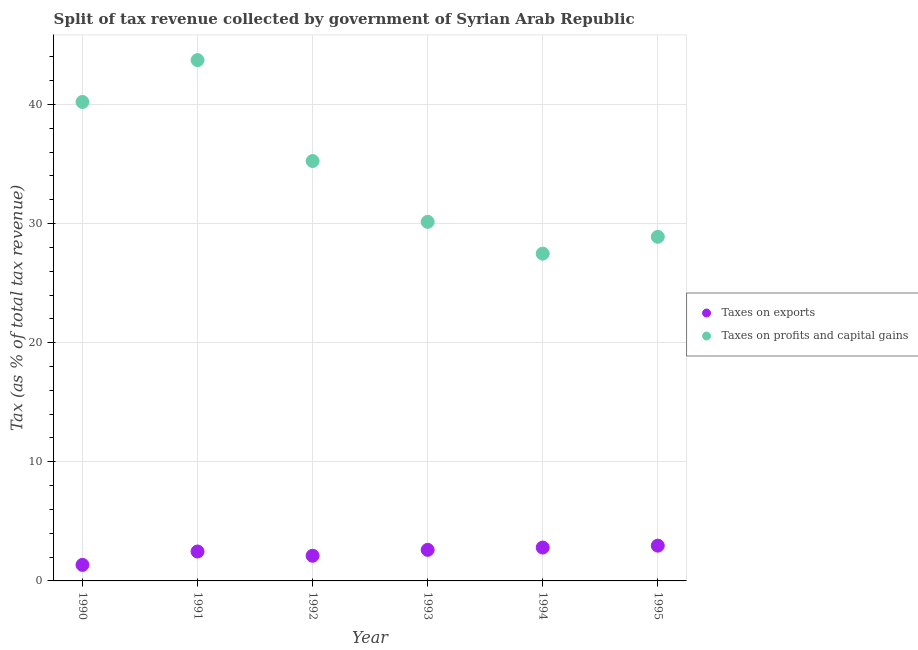How many different coloured dotlines are there?
Offer a very short reply. 2. Is the number of dotlines equal to the number of legend labels?
Offer a very short reply. Yes. What is the percentage of revenue obtained from taxes on profits and capital gains in 1995?
Offer a very short reply. 28.89. Across all years, what is the maximum percentage of revenue obtained from taxes on exports?
Ensure brevity in your answer.  2.96. Across all years, what is the minimum percentage of revenue obtained from taxes on exports?
Offer a terse response. 1.35. In which year was the percentage of revenue obtained from taxes on exports minimum?
Ensure brevity in your answer.  1990. What is the total percentage of revenue obtained from taxes on profits and capital gains in the graph?
Offer a very short reply. 205.68. What is the difference between the percentage of revenue obtained from taxes on exports in 1990 and that in 1991?
Your answer should be compact. -1.12. What is the difference between the percentage of revenue obtained from taxes on profits and capital gains in 1990 and the percentage of revenue obtained from taxes on exports in 1995?
Provide a succinct answer. 37.24. What is the average percentage of revenue obtained from taxes on profits and capital gains per year?
Provide a short and direct response. 34.28. In the year 1991, what is the difference between the percentage of revenue obtained from taxes on profits and capital gains and percentage of revenue obtained from taxes on exports?
Keep it short and to the point. 41.25. What is the ratio of the percentage of revenue obtained from taxes on exports in 1991 to that in 1993?
Keep it short and to the point. 0.95. Is the percentage of revenue obtained from taxes on profits and capital gains in 1990 less than that in 1995?
Provide a short and direct response. No. What is the difference between the highest and the second highest percentage of revenue obtained from taxes on profits and capital gains?
Your answer should be compact. 3.52. What is the difference between the highest and the lowest percentage of revenue obtained from taxes on exports?
Keep it short and to the point. 1.61. In how many years, is the percentage of revenue obtained from taxes on profits and capital gains greater than the average percentage of revenue obtained from taxes on profits and capital gains taken over all years?
Provide a succinct answer. 3. Is the percentage of revenue obtained from taxes on profits and capital gains strictly less than the percentage of revenue obtained from taxes on exports over the years?
Offer a very short reply. No. How many dotlines are there?
Offer a very short reply. 2. How many years are there in the graph?
Keep it short and to the point. 6. Does the graph contain grids?
Your answer should be very brief. Yes. Where does the legend appear in the graph?
Provide a short and direct response. Center right. How many legend labels are there?
Offer a very short reply. 2. What is the title of the graph?
Keep it short and to the point. Split of tax revenue collected by government of Syrian Arab Republic. Does "US$" appear as one of the legend labels in the graph?
Provide a succinct answer. No. What is the label or title of the X-axis?
Give a very brief answer. Year. What is the label or title of the Y-axis?
Your response must be concise. Tax (as % of total tax revenue). What is the Tax (as % of total tax revenue) in Taxes on exports in 1990?
Provide a succinct answer. 1.35. What is the Tax (as % of total tax revenue) in Taxes on profits and capital gains in 1990?
Give a very brief answer. 40.2. What is the Tax (as % of total tax revenue) of Taxes on exports in 1991?
Your answer should be compact. 2.47. What is the Tax (as % of total tax revenue) in Taxes on profits and capital gains in 1991?
Provide a short and direct response. 43.72. What is the Tax (as % of total tax revenue) in Taxes on exports in 1992?
Provide a succinct answer. 2.11. What is the Tax (as % of total tax revenue) in Taxes on profits and capital gains in 1992?
Your answer should be very brief. 35.25. What is the Tax (as % of total tax revenue) in Taxes on exports in 1993?
Provide a short and direct response. 2.61. What is the Tax (as % of total tax revenue) in Taxes on profits and capital gains in 1993?
Offer a very short reply. 30.14. What is the Tax (as % of total tax revenue) of Taxes on exports in 1994?
Offer a very short reply. 2.8. What is the Tax (as % of total tax revenue) of Taxes on profits and capital gains in 1994?
Your response must be concise. 27.47. What is the Tax (as % of total tax revenue) in Taxes on exports in 1995?
Keep it short and to the point. 2.96. What is the Tax (as % of total tax revenue) in Taxes on profits and capital gains in 1995?
Offer a terse response. 28.89. Across all years, what is the maximum Tax (as % of total tax revenue) in Taxes on exports?
Provide a succinct answer. 2.96. Across all years, what is the maximum Tax (as % of total tax revenue) in Taxes on profits and capital gains?
Provide a short and direct response. 43.72. Across all years, what is the minimum Tax (as % of total tax revenue) of Taxes on exports?
Offer a very short reply. 1.35. Across all years, what is the minimum Tax (as % of total tax revenue) in Taxes on profits and capital gains?
Provide a succinct answer. 27.47. What is the total Tax (as % of total tax revenue) of Taxes on exports in the graph?
Provide a short and direct response. 14.3. What is the total Tax (as % of total tax revenue) of Taxes on profits and capital gains in the graph?
Give a very brief answer. 205.68. What is the difference between the Tax (as % of total tax revenue) in Taxes on exports in 1990 and that in 1991?
Give a very brief answer. -1.12. What is the difference between the Tax (as % of total tax revenue) in Taxes on profits and capital gains in 1990 and that in 1991?
Your answer should be compact. -3.52. What is the difference between the Tax (as % of total tax revenue) of Taxes on exports in 1990 and that in 1992?
Offer a very short reply. -0.77. What is the difference between the Tax (as % of total tax revenue) of Taxes on profits and capital gains in 1990 and that in 1992?
Your response must be concise. 4.96. What is the difference between the Tax (as % of total tax revenue) in Taxes on exports in 1990 and that in 1993?
Your answer should be compact. -1.26. What is the difference between the Tax (as % of total tax revenue) of Taxes on profits and capital gains in 1990 and that in 1993?
Offer a terse response. 10.06. What is the difference between the Tax (as % of total tax revenue) in Taxes on exports in 1990 and that in 1994?
Offer a very short reply. -1.45. What is the difference between the Tax (as % of total tax revenue) in Taxes on profits and capital gains in 1990 and that in 1994?
Offer a terse response. 12.73. What is the difference between the Tax (as % of total tax revenue) of Taxes on exports in 1990 and that in 1995?
Make the answer very short. -1.61. What is the difference between the Tax (as % of total tax revenue) of Taxes on profits and capital gains in 1990 and that in 1995?
Your answer should be very brief. 11.32. What is the difference between the Tax (as % of total tax revenue) in Taxes on exports in 1991 and that in 1992?
Give a very brief answer. 0.36. What is the difference between the Tax (as % of total tax revenue) of Taxes on profits and capital gains in 1991 and that in 1992?
Ensure brevity in your answer.  8.47. What is the difference between the Tax (as % of total tax revenue) of Taxes on exports in 1991 and that in 1993?
Provide a short and direct response. -0.14. What is the difference between the Tax (as % of total tax revenue) of Taxes on profits and capital gains in 1991 and that in 1993?
Your answer should be compact. 13.58. What is the difference between the Tax (as % of total tax revenue) in Taxes on exports in 1991 and that in 1994?
Give a very brief answer. -0.33. What is the difference between the Tax (as % of total tax revenue) of Taxes on profits and capital gains in 1991 and that in 1994?
Your answer should be compact. 16.25. What is the difference between the Tax (as % of total tax revenue) of Taxes on exports in 1991 and that in 1995?
Your answer should be very brief. -0.49. What is the difference between the Tax (as % of total tax revenue) in Taxes on profits and capital gains in 1991 and that in 1995?
Your response must be concise. 14.83. What is the difference between the Tax (as % of total tax revenue) in Taxes on exports in 1992 and that in 1993?
Your answer should be very brief. -0.49. What is the difference between the Tax (as % of total tax revenue) of Taxes on profits and capital gains in 1992 and that in 1993?
Provide a short and direct response. 5.11. What is the difference between the Tax (as % of total tax revenue) of Taxes on exports in 1992 and that in 1994?
Give a very brief answer. -0.69. What is the difference between the Tax (as % of total tax revenue) of Taxes on profits and capital gains in 1992 and that in 1994?
Offer a terse response. 7.77. What is the difference between the Tax (as % of total tax revenue) of Taxes on exports in 1992 and that in 1995?
Offer a very short reply. -0.85. What is the difference between the Tax (as % of total tax revenue) of Taxes on profits and capital gains in 1992 and that in 1995?
Give a very brief answer. 6.36. What is the difference between the Tax (as % of total tax revenue) in Taxes on exports in 1993 and that in 1994?
Offer a terse response. -0.19. What is the difference between the Tax (as % of total tax revenue) in Taxes on profits and capital gains in 1993 and that in 1994?
Your answer should be very brief. 2.67. What is the difference between the Tax (as % of total tax revenue) in Taxes on exports in 1993 and that in 1995?
Offer a very short reply. -0.35. What is the difference between the Tax (as % of total tax revenue) of Taxes on profits and capital gains in 1993 and that in 1995?
Your response must be concise. 1.26. What is the difference between the Tax (as % of total tax revenue) of Taxes on exports in 1994 and that in 1995?
Keep it short and to the point. -0.16. What is the difference between the Tax (as % of total tax revenue) in Taxes on profits and capital gains in 1994 and that in 1995?
Your response must be concise. -1.41. What is the difference between the Tax (as % of total tax revenue) in Taxes on exports in 1990 and the Tax (as % of total tax revenue) in Taxes on profits and capital gains in 1991?
Ensure brevity in your answer.  -42.37. What is the difference between the Tax (as % of total tax revenue) of Taxes on exports in 1990 and the Tax (as % of total tax revenue) of Taxes on profits and capital gains in 1992?
Your answer should be compact. -33.9. What is the difference between the Tax (as % of total tax revenue) of Taxes on exports in 1990 and the Tax (as % of total tax revenue) of Taxes on profits and capital gains in 1993?
Make the answer very short. -28.8. What is the difference between the Tax (as % of total tax revenue) of Taxes on exports in 1990 and the Tax (as % of total tax revenue) of Taxes on profits and capital gains in 1994?
Give a very brief answer. -26.13. What is the difference between the Tax (as % of total tax revenue) of Taxes on exports in 1990 and the Tax (as % of total tax revenue) of Taxes on profits and capital gains in 1995?
Your answer should be compact. -27.54. What is the difference between the Tax (as % of total tax revenue) of Taxes on exports in 1991 and the Tax (as % of total tax revenue) of Taxes on profits and capital gains in 1992?
Your response must be concise. -32.78. What is the difference between the Tax (as % of total tax revenue) of Taxes on exports in 1991 and the Tax (as % of total tax revenue) of Taxes on profits and capital gains in 1993?
Offer a very short reply. -27.67. What is the difference between the Tax (as % of total tax revenue) in Taxes on exports in 1991 and the Tax (as % of total tax revenue) in Taxes on profits and capital gains in 1994?
Offer a terse response. -25. What is the difference between the Tax (as % of total tax revenue) of Taxes on exports in 1991 and the Tax (as % of total tax revenue) of Taxes on profits and capital gains in 1995?
Your answer should be compact. -26.42. What is the difference between the Tax (as % of total tax revenue) in Taxes on exports in 1992 and the Tax (as % of total tax revenue) in Taxes on profits and capital gains in 1993?
Provide a succinct answer. -28.03. What is the difference between the Tax (as % of total tax revenue) in Taxes on exports in 1992 and the Tax (as % of total tax revenue) in Taxes on profits and capital gains in 1994?
Provide a succinct answer. -25.36. What is the difference between the Tax (as % of total tax revenue) in Taxes on exports in 1992 and the Tax (as % of total tax revenue) in Taxes on profits and capital gains in 1995?
Make the answer very short. -26.77. What is the difference between the Tax (as % of total tax revenue) of Taxes on exports in 1993 and the Tax (as % of total tax revenue) of Taxes on profits and capital gains in 1994?
Your answer should be very brief. -24.87. What is the difference between the Tax (as % of total tax revenue) in Taxes on exports in 1993 and the Tax (as % of total tax revenue) in Taxes on profits and capital gains in 1995?
Give a very brief answer. -26.28. What is the difference between the Tax (as % of total tax revenue) of Taxes on exports in 1994 and the Tax (as % of total tax revenue) of Taxes on profits and capital gains in 1995?
Provide a succinct answer. -26.08. What is the average Tax (as % of total tax revenue) in Taxes on exports per year?
Your response must be concise. 2.38. What is the average Tax (as % of total tax revenue) of Taxes on profits and capital gains per year?
Your answer should be compact. 34.28. In the year 1990, what is the difference between the Tax (as % of total tax revenue) of Taxes on exports and Tax (as % of total tax revenue) of Taxes on profits and capital gains?
Give a very brief answer. -38.86. In the year 1991, what is the difference between the Tax (as % of total tax revenue) of Taxes on exports and Tax (as % of total tax revenue) of Taxes on profits and capital gains?
Provide a succinct answer. -41.25. In the year 1992, what is the difference between the Tax (as % of total tax revenue) of Taxes on exports and Tax (as % of total tax revenue) of Taxes on profits and capital gains?
Provide a short and direct response. -33.14. In the year 1993, what is the difference between the Tax (as % of total tax revenue) of Taxes on exports and Tax (as % of total tax revenue) of Taxes on profits and capital gains?
Provide a succinct answer. -27.53. In the year 1994, what is the difference between the Tax (as % of total tax revenue) of Taxes on exports and Tax (as % of total tax revenue) of Taxes on profits and capital gains?
Your response must be concise. -24.67. In the year 1995, what is the difference between the Tax (as % of total tax revenue) of Taxes on exports and Tax (as % of total tax revenue) of Taxes on profits and capital gains?
Make the answer very short. -25.93. What is the ratio of the Tax (as % of total tax revenue) of Taxes on exports in 1990 to that in 1991?
Offer a very short reply. 0.55. What is the ratio of the Tax (as % of total tax revenue) in Taxes on profits and capital gains in 1990 to that in 1991?
Make the answer very short. 0.92. What is the ratio of the Tax (as % of total tax revenue) of Taxes on exports in 1990 to that in 1992?
Your answer should be compact. 0.64. What is the ratio of the Tax (as % of total tax revenue) in Taxes on profits and capital gains in 1990 to that in 1992?
Keep it short and to the point. 1.14. What is the ratio of the Tax (as % of total tax revenue) of Taxes on exports in 1990 to that in 1993?
Make the answer very short. 0.52. What is the ratio of the Tax (as % of total tax revenue) of Taxes on profits and capital gains in 1990 to that in 1993?
Keep it short and to the point. 1.33. What is the ratio of the Tax (as % of total tax revenue) in Taxes on exports in 1990 to that in 1994?
Provide a short and direct response. 0.48. What is the ratio of the Tax (as % of total tax revenue) of Taxes on profits and capital gains in 1990 to that in 1994?
Provide a succinct answer. 1.46. What is the ratio of the Tax (as % of total tax revenue) in Taxes on exports in 1990 to that in 1995?
Offer a terse response. 0.46. What is the ratio of the Tax (as % of total tax revenue) of Taxes on profits and capital gains in 1990 to that in 1995?
Keep it short and to the point. 1.39. What is the ratio of the Tax (as % of total tax revenue) in Taxes on exports in 1991 to that in 1992?
Your answer should be compact. 1.17. What is the ratio of the Tax (as % of total tax revenue) in Taxes on profits and capital gains in 1991 to that in 1992?
Your answer should be compact. 1.24. What is the ratio of the Tax (as % of total tax revenue) of Taxes on exports in 1991 to that in 1993?
Provide a succinct answer. 0.95. What is the ratio of the Tax (as % of total tax revenue) of Taxes on profits and capital gains in 1991 to that in 1993?
Ensure brevity in your answer.  1.45. What is the ratio of the Tax (as % of total tax revenue) in Taxes on exports in 1991 to that in 1994?
Offer a very short reply. 0.88. What is the ratio of the Tax (as % of total tax revenue) of Taxes on profits and capital gains in 1991 to that in 1994?
Your answer should be compact. 1.59. What is the ratio of the Tax (as % of total tax revenue) in Taxes on exports in 1991 to that in 1995?
Ensure brevity in your answer.  0.83. What is the ratio of the Tax (as % of total tax revenue) in Taxes on profits and capital gains in 1991 to that in 1995?
Offer a terse response. 1.51. What is the ratio of the Tax (as % of total tax revenue) of Taxes on exports in 1992 to that in 1993?
Keep it short and to the point. 0.81. What is the ratio of the Tax (as % of total tax revenue) in Taxes on profits and capital gains in 1992 to that in 1993?
Offer a terse response. 1.17. What is the ratio of the Tax (as % of total tax revenue) of Taxes on exports in 1992 to that in 1994?
Ensure brevity in your answer.  0.75. What is the ratio of the Tax (as % of total tax revenue) of Taxes on profits and capital gains in 1992 to that in 1994?
Your response must be concise. 1.28. What is the ratio of the Tax (as % of total tax revenue) of Taxes on exports in 1992 to that in 1995?
Your answer should be compact. 0.71. What is the ratio of the Tax (as % of total tax revenue) of Taxes on profits and capital gains in 1992 to that in 1995?
Ensure brevity in your answer.  1.22. What is the ratio of the Tax (as % of total tax revenue) of Taxes on exports in 1993 to that in 1994?
Provide a short and direct response. 0.93. What is the ratio of the Tax (as % of total tax revenue) in Taxes on profits and capital gains in 1993 to that in 1994?
Your answer should be very brief. 1.1. What is the ratio of the Tax (as % of total tax revenue) of Taxes on exports in 1993 to that in 1995?
Make the answer very short. 0.88. What is the ratio of the Tax (as % of total tax revenue) in Taxes on profits and capital gains in 1993 to that in 1995?
Your answer should be compact. 1.04. What is the ratio of the Tax (as % of total tax revenue) in Taxes on exports in 1994 to that in 1995?
Your response must be concise. 0.95. What is the ratio of the Tax (as % of total tax revenue) in Taxes on profits and capital gains in 1994 to that in 1995?
Ensure brevity in your answer.  0.95. What is the difference between the highest and the second highest Tax (as % of total tax revenue) of Taxes on exports?
Keep it short and to the point. 0.16. What is the difference between the highest and the second highest Tax (as % of total tax revenue) of Taxes on profits and capital gains?
Your response must be concise. 3.52. What is the difference between the highest and the lowest Tax (as % of total tax revenue) in Taxes on exports?
Give a very brief answer. 1.61. What is the difference between the highest and the lowest Tax (as % of total tax revenue) of Taxes on profits and capital gains?
Offer a very short reply. 16.25. 